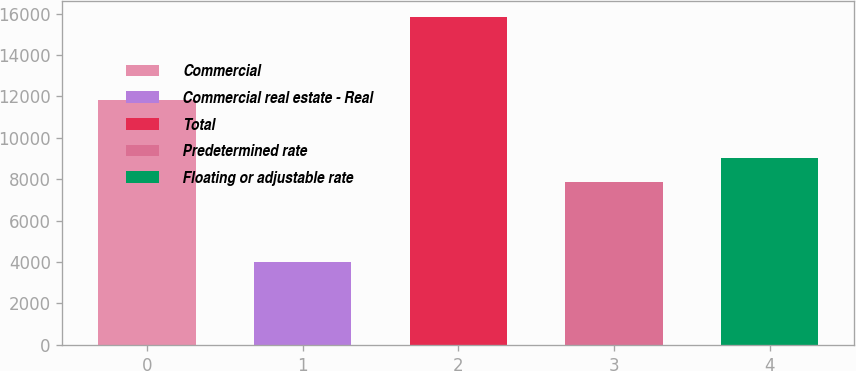Convert chart to OTSL. <chart><loc_0><loc_0><loc_500><loc_500><bar_chart><fcel>Commercial<fcel>Commercial real estate - Real<fcel>Total<fcel>Predetermined rate<fcel>Floating or adjustable rate<nl><fcel>11808<fcel>4010<fcel>15818<fcel>7855<fcel>9035.8<nl></chart> 